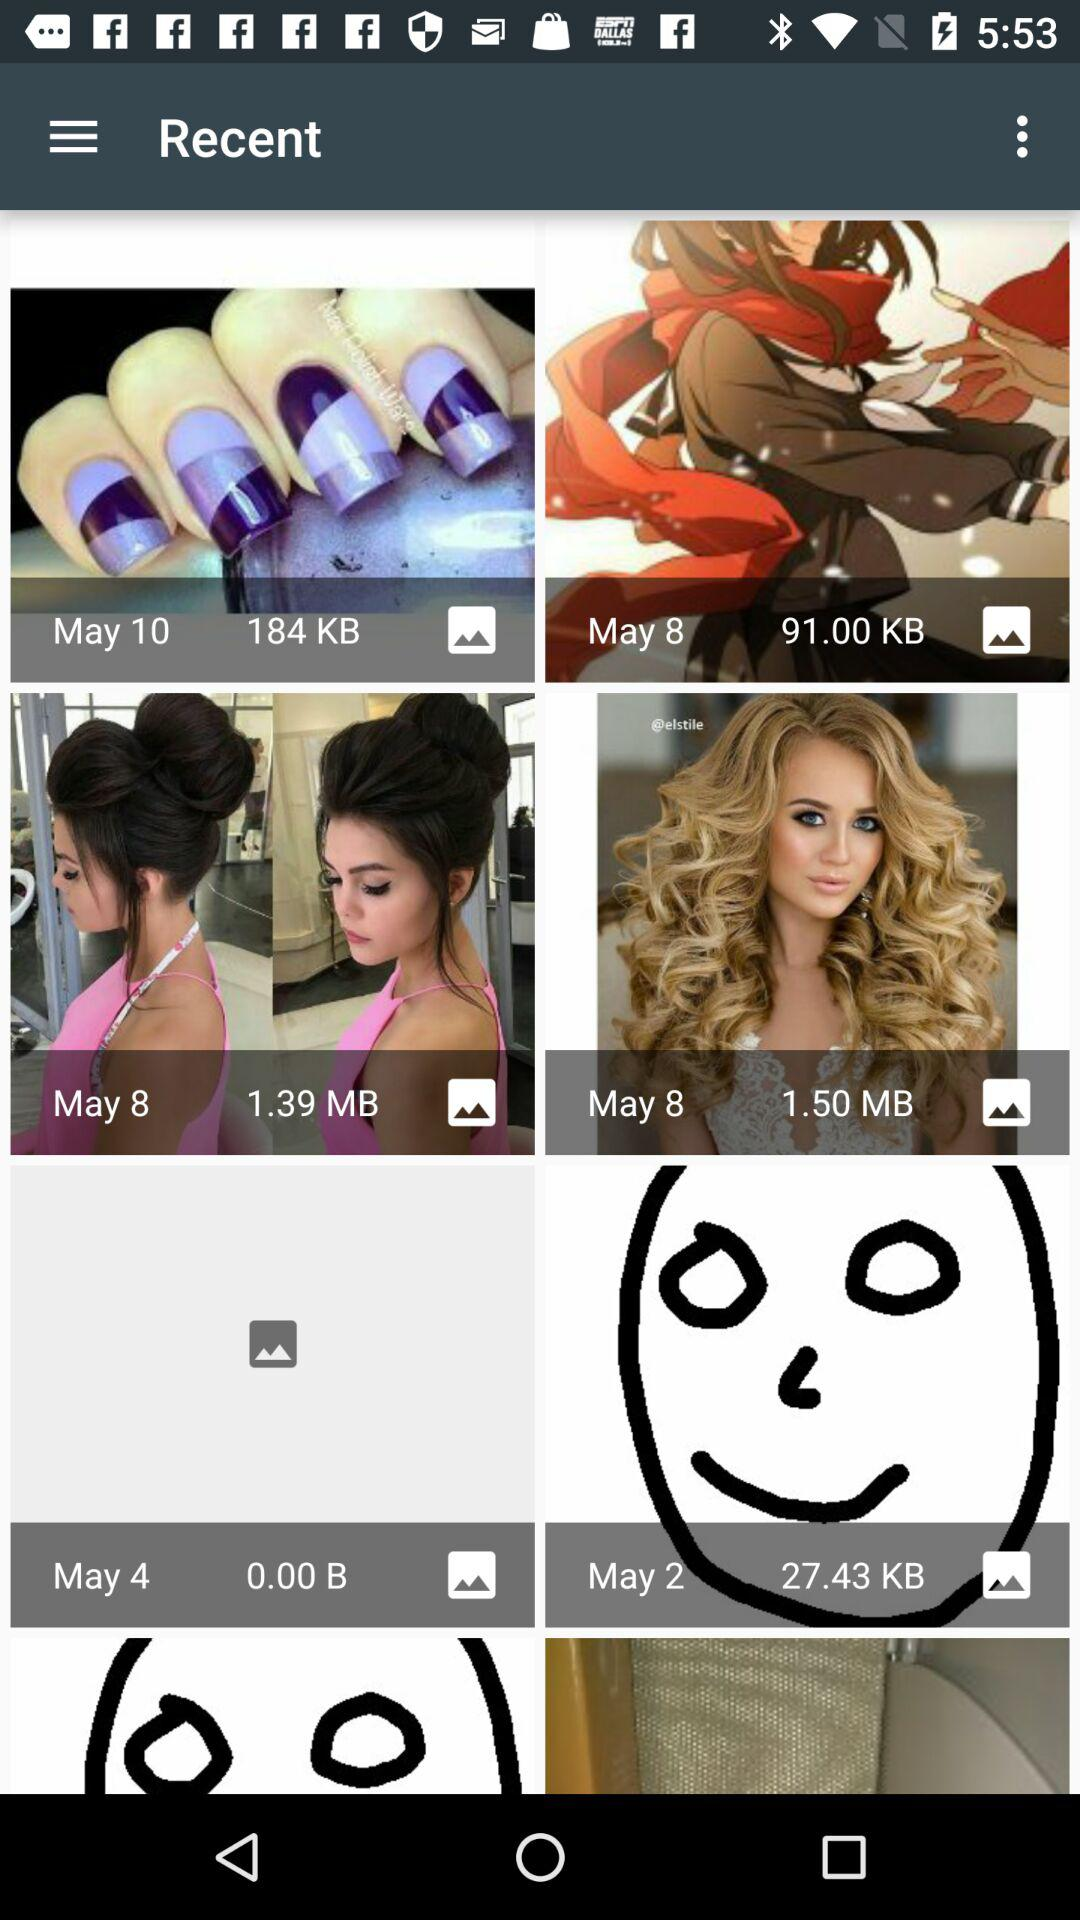On which date was the picture of 1.50 MB taken? The picture of 1.50 MB was taken on May 8. 